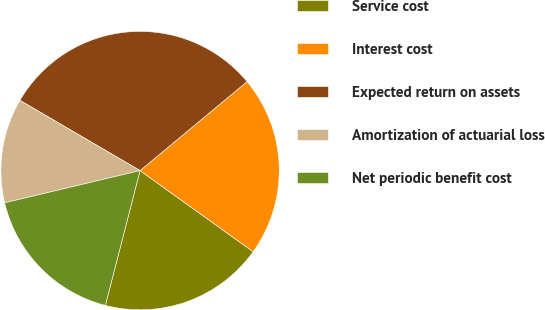<chart> <loc_0><loc_0><loc_500><loc_500><pie_chart><fcel>Service cost<fcel>Interest cost<fcel>Expected return on assets<fcel>Amortization of actuarial loss<fcel>Net periodic benefit cost<nl><fcel>19.11%<fcel>20.95%<fcel>30.54%<fcel>12.14%<fcel>17.27%<nl></chart> 